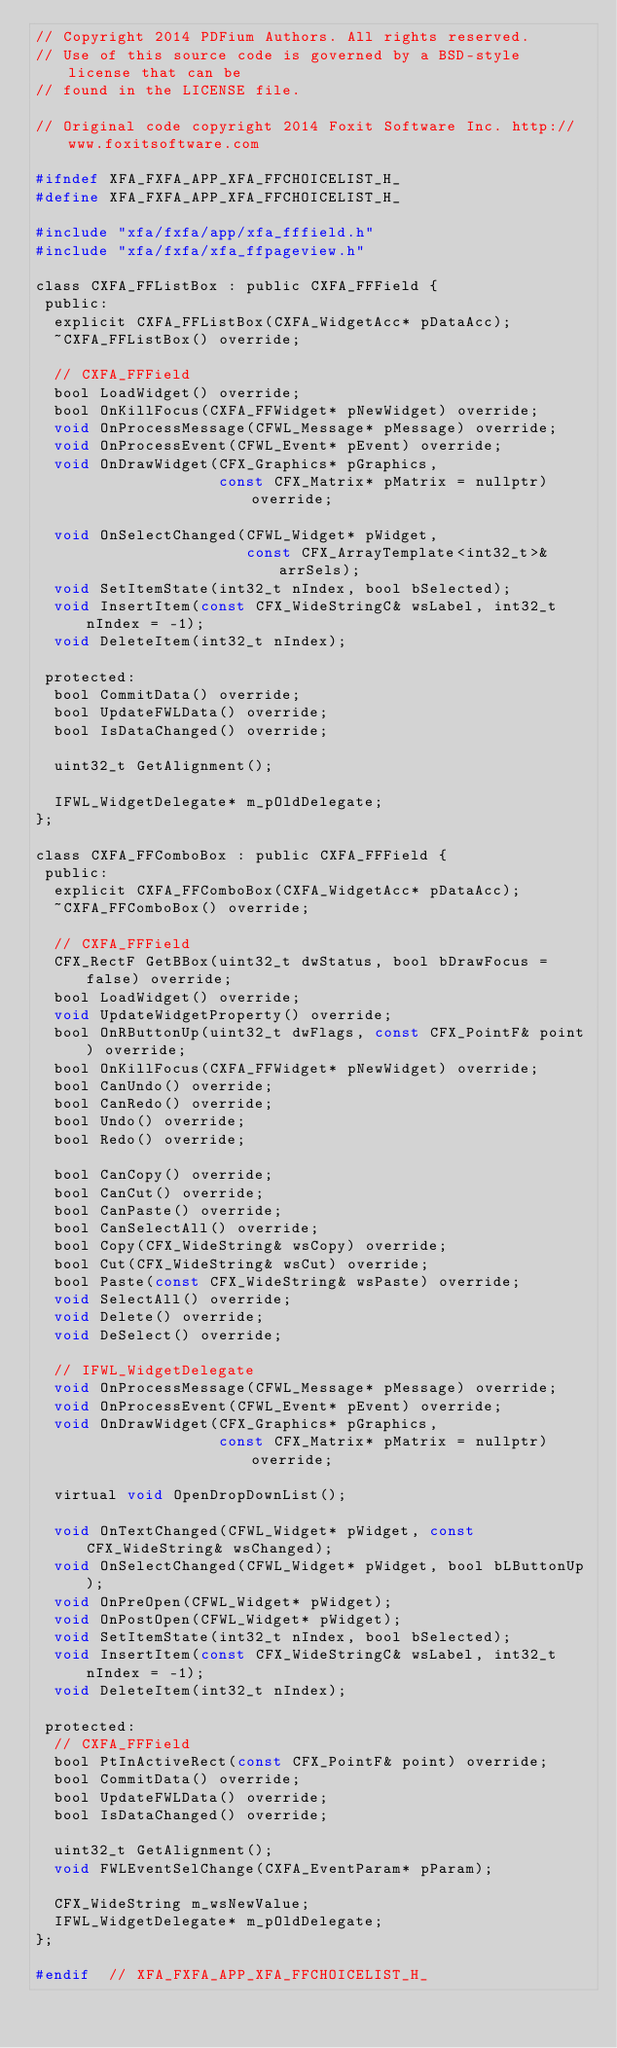Convert code to text. <code><loc_0><loc_0><loc_500><loc_500><_C_>// Copyright 2014 PDFium Authors. All rights reserved.
// Use of this source code is governed by a BSD-style license that can be
// found in the LICENSE file.

// Original code copyright 2014 Foxit Software Inc. http://www.foxitsoftware.com

#ifndef XFA_FXFA_APP_XFA_FFCHOICELIST_H_
#define XFA_FXFA_APP_XFA_FFCHOICELIST_H_

#include "xfa/fxfa/app/xfa_fffield.h"
#include "xfa/fxfa/xfa_ffpageview.h"

class CXFA_FFListBox : public CXFA_FFField {
 public:
  explicit CXFA_FFListBox(CXFA_WidgetAcc* pDataAcc);
  ~CXFA_FFListBox() override;

  // CXFA_FFField
  bool LoadWidget() override;
  bool OnKillFocus(CXFA_FFWidget* pNewWidget) override;
  void OnProcessMessage(CFWL_Message* pMessage) override;
  void OnProcessEvent(CFWL_Event* pEvent) override;
  void OnDrawWidget(CFX_Graphics* pGraphics,
                    const CFX_Matrix* pMatrix = nullptr) override;

  void OnSelectChanged(CFWL_Widget* pWidget,
                       const CFX_ArrayTemplate<int32_t>& arrSels);
  void SetItemState(int32_t nIndex, bool bSelected);
  void InsertItem(const CFX_WideStringC& wsLabel, int32_t nIndex = -1);
  void DeleteItem(int32_t nIndex);

 protected:
  bool CommitData() override;
  bool UpdateFWLData() override;
  bool IsDataChanged() override;

  uint32_t GetAlignment();

  IFWL_WidgetDelegate* m_pOldDelegate;
};

class CXFA_FFComboBox : public CXFA_FFField {
 public:
  explicit CXFA_FFComboBox(CXFA_WidgetAcc* pDataAcc);
  ~CXFA_FFComboBox() override;

  // CXFA_FFField
  CFX_RectF GetBBox(uint32_t dwStatus, bool bDrawFocus = false) override;
  bool LoadWidget() override;
  void UpdateWidgetProperty() override;
  bool OnRButtonUp(uint32_t dwFlags, const CFX_PointF& point) override;
  bool OnKillFocus(CXFA_FFWidget* pNewWidget) override;
  bool CanUndo() override;
  bool CanRedo() override;
  bool Undo() override;
  bool Redo() override;

  bool CanCopy() override;
  bool CanCut() override;
  bool CanPaste() override;
  bool CanSelectAll() override;
  bool Copy(CFX_WideString& wsCopy) override;
  bool Cut(CFX_WideString& wsCut) override;
  bool Paste(const CFX_WideString& wsPaste) override;
  void SelectAll() override;
  void Delete() override;
  void DeSelect() override;

  // IFWL_WidgetDelegate
  void OnProcessMessage(CFWL_Message* pMessage) override;
  void OnProcessEvent(CFWL_Event* pEvent) override;
  void OnDrawWidget(CFX_Graphics* pGraphics,
                    const CFX_Matrix* pMatrix = nullptr) override;

  virtual void OpenDropDownList();

  void OnTextChanged(CFWL_Widget* pWidget, const CFX_WideString& wsChanged);
  void OnSelectChanged(CFWL_Widget* pWidget, bool bLButtonUp);
  void OnPreOpen(CFWL_Widget* pWidget);
  void OnPostOpen(CFWL_Widget* pWidget);
  void SetItemState(int32_t nIndex, bool bSelected);
  void InsertItem(const CFX_WideStringC& wsLabel, int32_t nIndex = -1);
  void DeleteItem(int32_t nIndex);

 protected:
  // CXFA_FFField
  bool PtInActiveRect(const CFX_PointF& point) override;
  bool CommitData() override;
  bool UpdateFWLData() override;
  bool IsDataChanged() override;

  uint32_t GetAlignment();
  void FWLEventSelChange(CXFA_EventParam* pParam);

  CFX_WideString m_wsNewValue;
  IFWL_WidgetDelegate* m_pOldDelegate;
};

#endif  // XFA_FXFA_APP_XFA_FFCHOICELIST_H_
</code> 